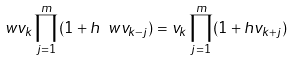Convert formula to latex. <formula><loc_0><loc_0><loc_500><loc_500>\ w v _ { k } \prod _ { j = 1 } ^ { m } ( 1 + h \ w v _ { k - j } ) = v _ { k } \prod _ { j = 1 } ^ { m } ( 1 + h v _ { k + j } )</formula> 